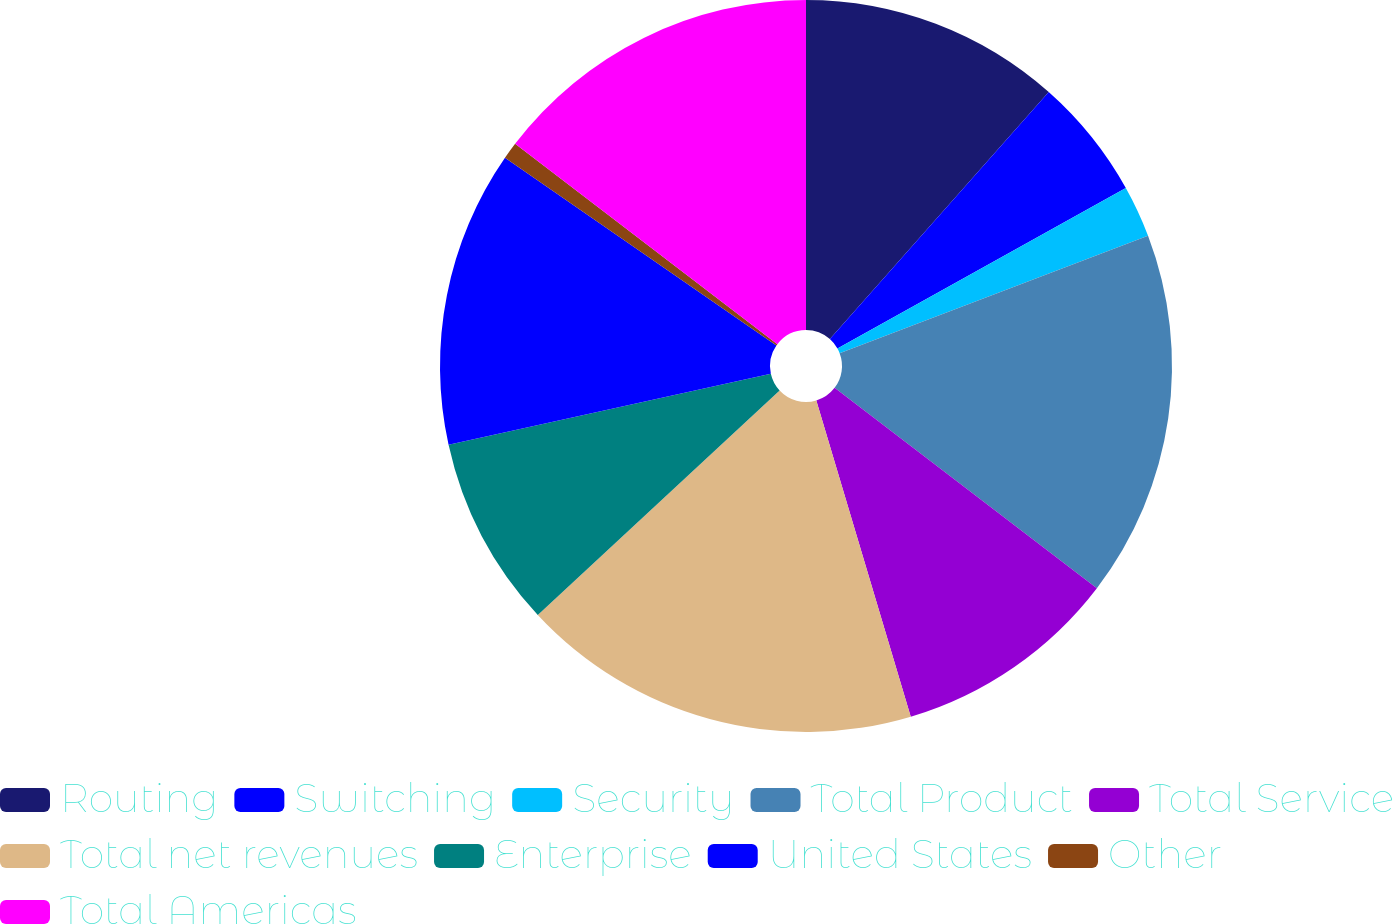Convert chart to OTSL. <chart><loc_0><loc_0><loc_500><loc_500><pie_chart><fcel>Routing<fcel>Switching<fcel>Security<fcel>Total Product<fcel>Total Service<fcel>Total net revenues<fcel>Enterprise<fcel>United States<fcel>Other<fcel>Total Americas<nl><fcel>11.54%<fcel>5.38%<fcel>2.29%<fcel>16.17%<fcel>10.0%<fcel>17.71%<fcel>8.46%<fcel>13.08%<fcel>0.75%<fcel>14.62%<nl></chart> 